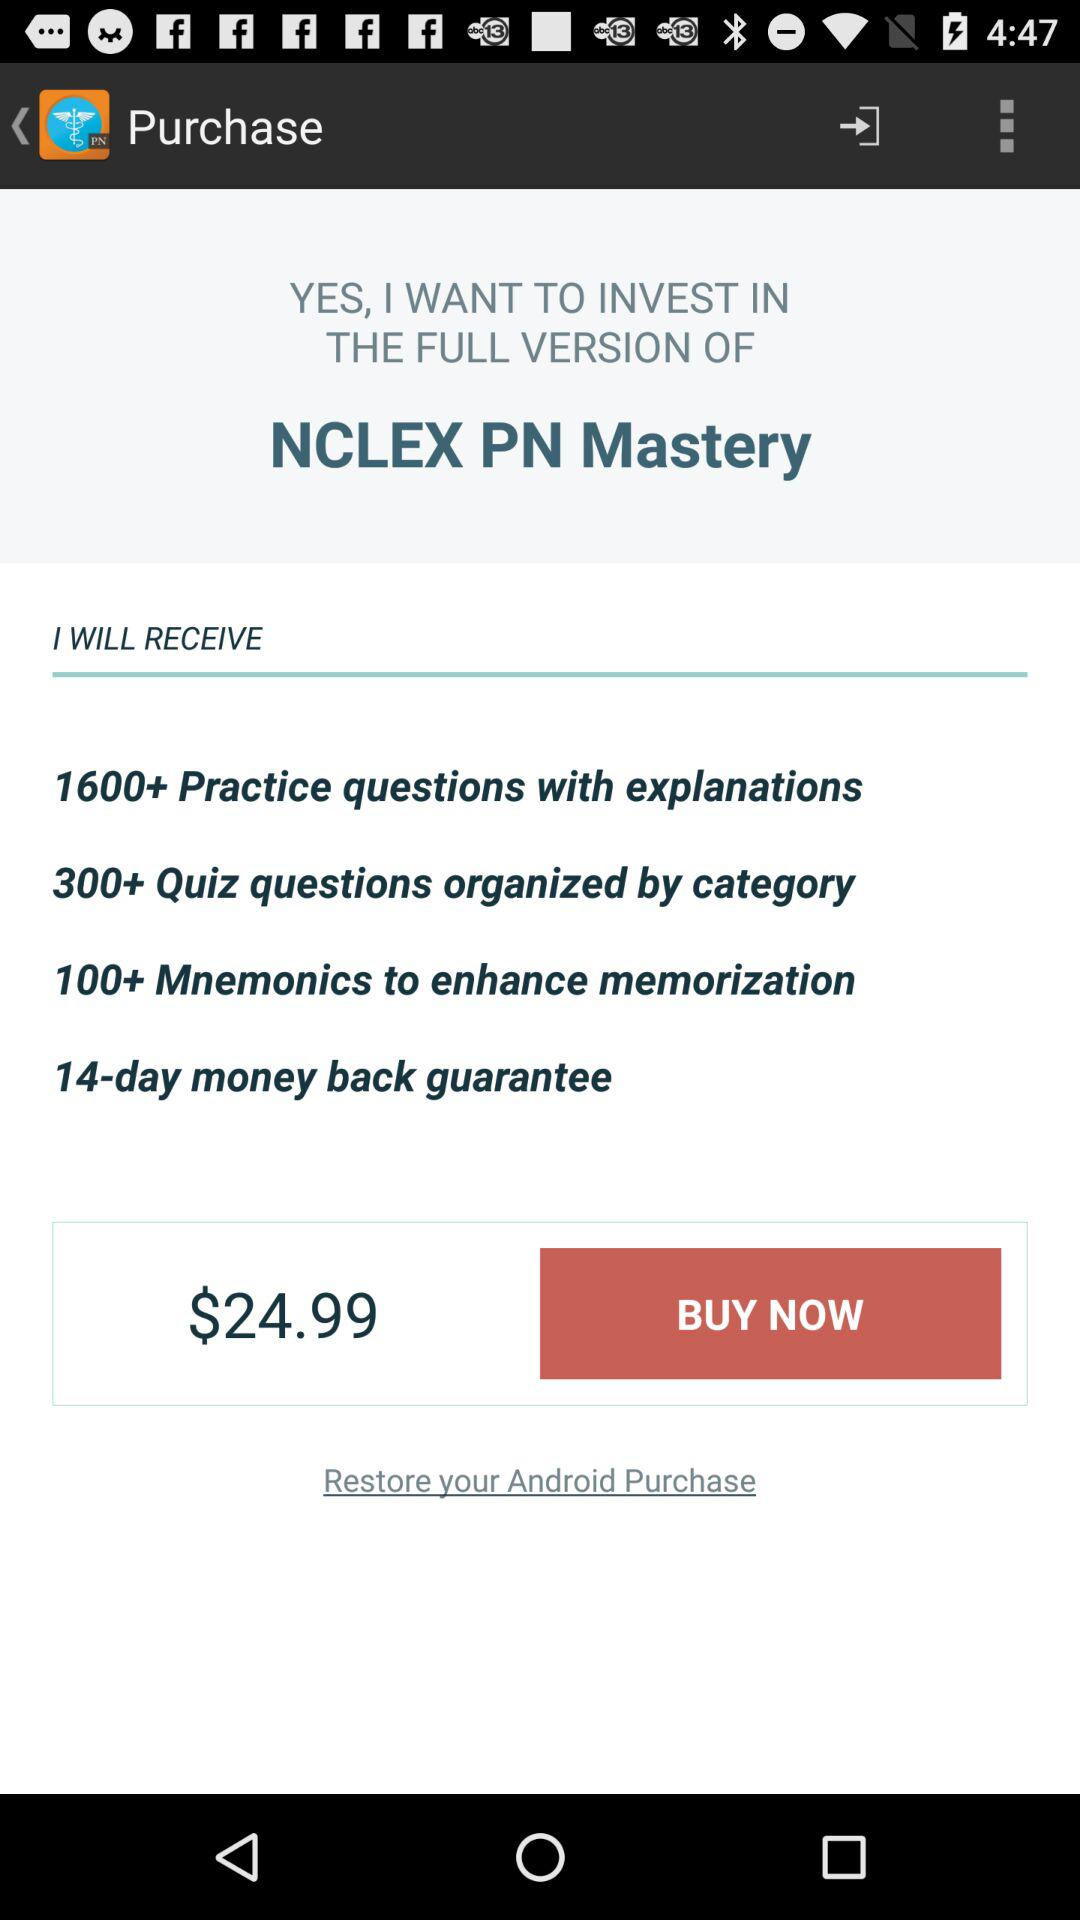What is the price for "NCLEX PN Mastery"? The price is $24.99. 